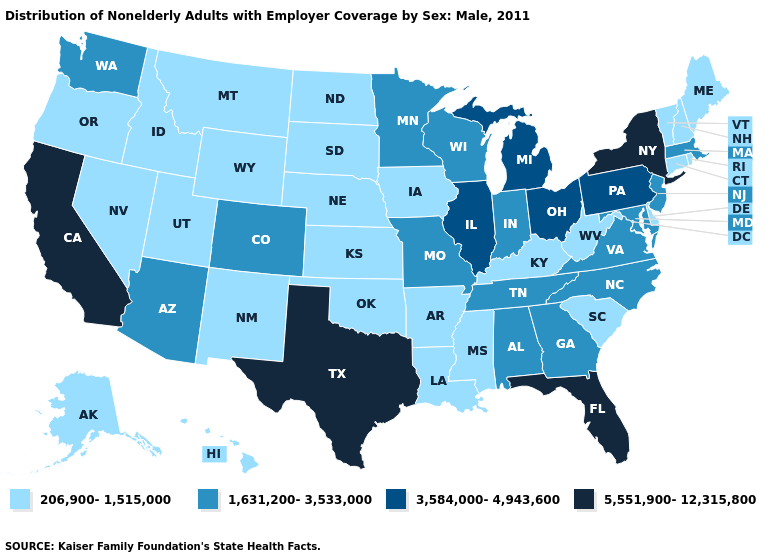What is the highest value in the USA?
Short answer required. 5,551,900-12,315,800. What is the value of Mississippi?
Give a very brief answer. 206,900-1,515,000. Name the states that have a value in the range 206,900-1,515,000?
Concise answer only. Alaska, Arkansas, Connecticut, Delaware, Hawaii, Idaho, Iowa, Kansas, Kentucky, Louisiana, Maine, Mississippi, Montana, Nebraska, Nevada, New Hampshire, New Mexico, North Dakota, Oklahoma, Oregon, Rhode Island, South Carolina, South Dakota, Utah, Vermont, West Virginia, Wyoming. Does the first symbol in the legend represent the smallest category?
Quick response, please. Yes. What is the value of Florida?
Write a very short answer. 5,551,900-12,315,800. What is the highest value in the USA?
Keep it brief. 5,551,900-12,315,800. Which states have the lowest value in the USA?
Keep it brief. Alaska, Arkansas, Connecticut, Delaware, Hawaii, Idaho, Iowa, Kansas, Kentucky, Louisiana, Maine, Mississippi, Montana, Nebraska, Nevada, New Hampshire, New Mexico, North Dakota, Oklahoma, Oregon, Rhode Island, South Carolina, South Dakota, Utah, Vermont, West Virginia, Wyoming. Name the states that have a value in the range 206,900-1,515,000?
Quick response, please. Alaska, Arkansas, Connecticut, Delaware, Hawaii, Idaho, Iowa, Kansas, Kentucky, Louisiana, Maine, Mississippi, Montana, Nebraska, Nevada, New Hampshire, New Mexico, North Dakota, Oklahoma, Oregon, Rhode Island, South Carolina, South Dakota, Utah, Vermont, West Virginia, Wyoming. What is the highest value in the Northeast ?
Keep it brief. 5,551,900-12,315,800. Name the states that have a value in the range 5,551,900-12,315,800?
Short answer required. California, Florida, New York, Texas. Among the states that border Minnesota , which have the highest value?
Short answer required. Wisconsin. What is the value of Michigan?
Write a very short answer. 3,584,000-4,943,600. Among the states that border New Mexico , which have the lowest value?
Short answer required. Oklahoma, Utah. What is the highest value in states that border New Hampshire?
Quick response, please. 1,631,200-3,533,000. 